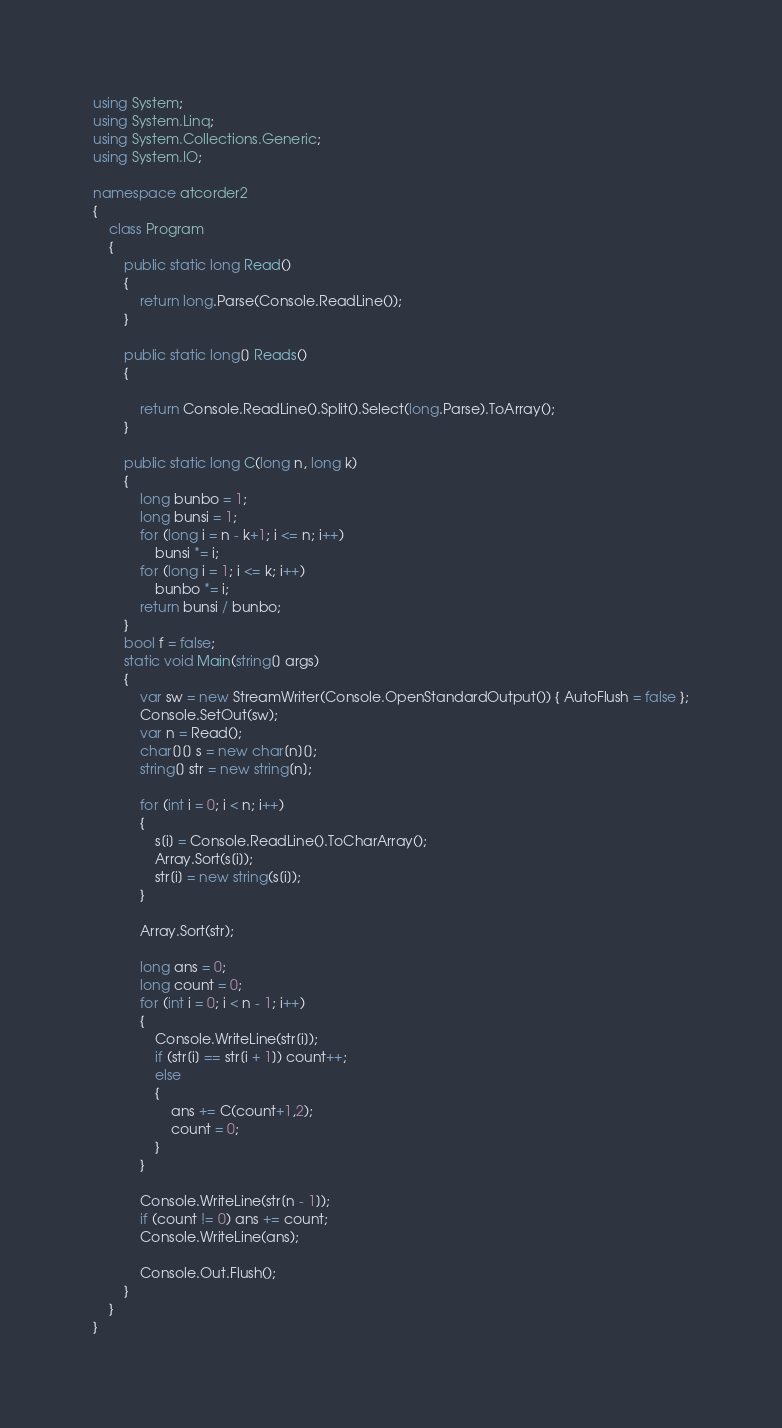<code> <loc_0><loc_0><loc_500><loc_500><_C#_>using System;
using System.Linq;
using System.Collections.Generic;
using System.IO;

namespace atcorder2
{
    class Program
    {
        public static long Read()
        {
            return long.Parse(Console.ReadLine());
        }

        public static long[] Reads()
        {

            return Console.ReadLine().Split().Select(long.Parse).ToArray();
        }

        public static long C(long n, long k)
        {
            long bunbo = 1;
            long bunsi = 1;
            for (long i = n - k+1; i <= n; i++)
                bunsi *= i;
            for (long i = 1; i <= k; i++)
                bunbo *= i;
            return bunsi / bunbo;
        }
        bool f = false;
        static void Main(string[] args)
        {
            var sw = new StreamWriter(Console.OpenStandardOutput()) { AutoFlush = false };
            Console.SetOut(sw);
            var n = Read();
            char[][] s = new char[n][];
            string[] str = new string[n];

            for (int i = 0; i < n; i++)
            {
                s[i] = Console.ReadLine().ToCharArray();
                Array.Sort(s[i]);
                str[i] = new string(s[i]);
            }

            Array.Sort(str);

            long ans = 0;
            long count = 0;
            for (int i = 0; i < n - 1; i++)
            {
                Console.WriteLine(str[i]);
                if (str[i] == str[i + 1]) count++;
                else
                {
                    ans += C(count+1,2);
                    count = 0;
                }
            }

            Console.WriteLine(str[n - 1]);
            if (count != 0) ans += count;
            Console.WriteLine(ans);
   
            Console.Out.Flush();
        }
    }
}</code> 